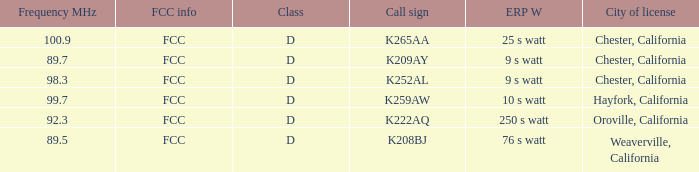Name the call sign with frequency of 89.5 K208BJ. 